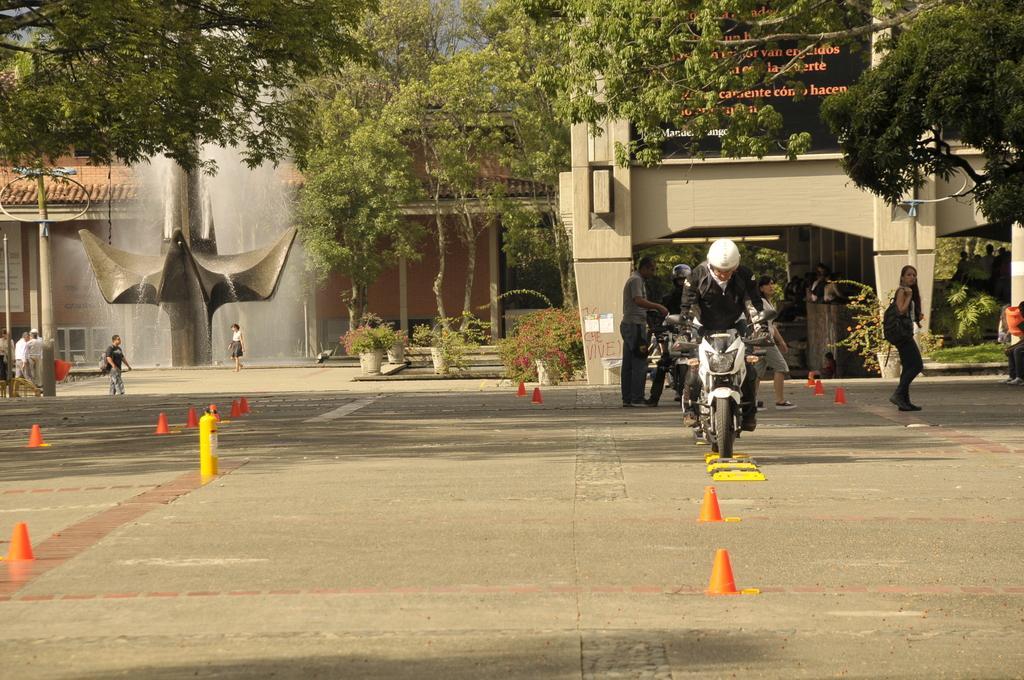Can you describe this image briefly? In this image i can see a man riding the bike on the road, at the back ground i can see a lady walking,few man standing and a tree, and a building and a water fall. 